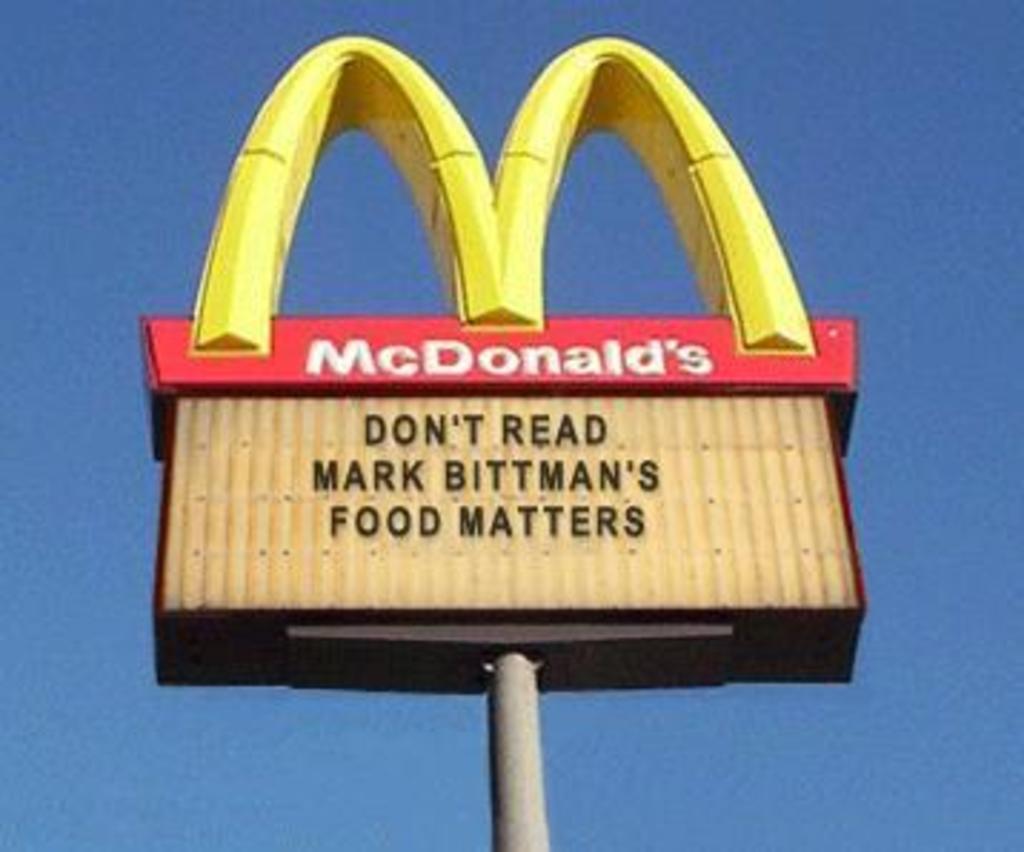What does the sign say matters?
Provide a succinct answer. Food. 